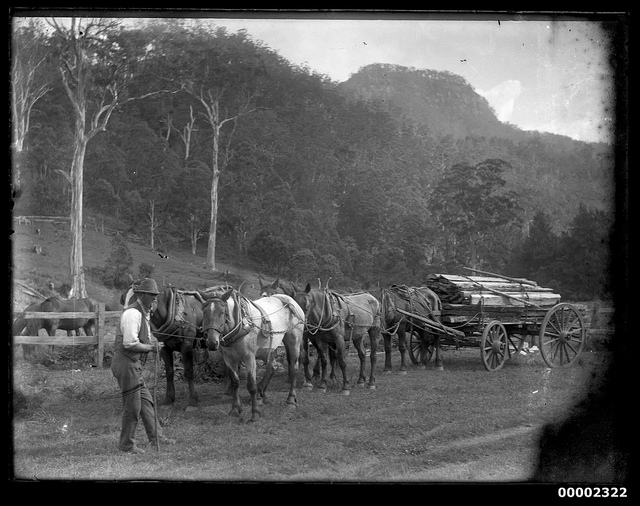How many wheels does the wagon have? 4 